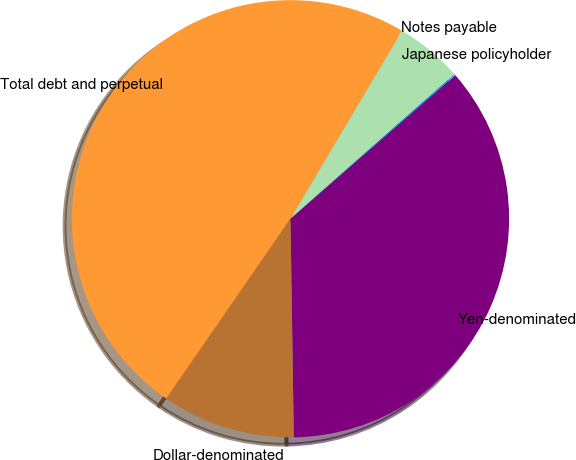Convert chart to OTSL. <chart><loc_0><loc_0><loc_500><loc_500><pie_chart><fcel>Yen-denominated<fcel>Dollar-denominated<fcel>Total debt and perpetual<fcel>Notes payable<fcel>Japanese policyholder<nl><fcel>36.15%<fcel>9.86%<fcel>48.9%<fcel>4.98%<fcel>0.1%<nl></chart> 